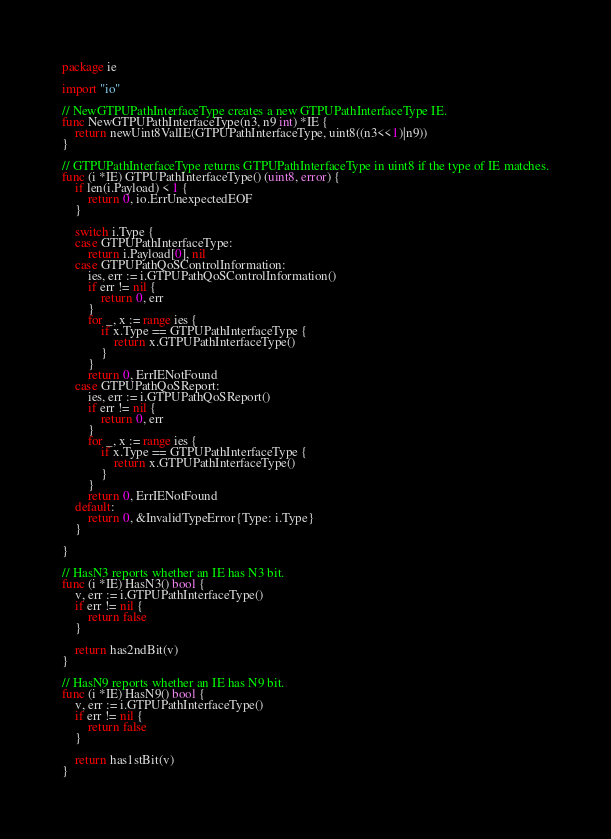<code> <loc_0><loc_0><loc_500><loc_500><_Go_>
package ie

import "io"

// NewGTPUPathInterfaceType creates a new GTPUPathInterfaceType IE.
func NewGTPUPathInterfaceType(n3, n9 int) *IE {
	return newUint8ValIE(GTPUPathInterfaceType, uint8((n3<<1)|n9))
}

// GTPUPathInterfaceType returns GTPUPathInterfaceType in uint8 if the type of IE matches.
func (i *IE) GTPUPathInterfaceType() (uint8, error) {
	if len(i.Payload) < 1 {
		return 0, io.ErrUnexpectedEOF
	}

	switch i.Type {
	case GTPUPathInterfaceType:
		return i.Payload[0], nil
	case GTPUPathQoSControlInformation:
		ies, err := i.GTPUPathQoSControlInformation()
		if err != nil {
			return 0, err
		}
		for _, x := range ies {
			if x.Type == GTPUPathInterfaceType {
				return x.GTPUPathInterfaceType()
			}
		}
		return 0, ErrIENotFound
	case GTPUPathQoSReport:
		ies, err := i.GTPUPathQoSReport()
		if err != nil {
			return 0, err
		}
		for _, x := range ies {
			if x.Type == GTPUPathInterfaceType {
				return x.GTPUPathInterfaceType()
			}
		}
		return 0, ErrIENotFound
	default:
		return 0, &InvalidTypeError{Type: i.Type}
	}

}

// HasN3 reports whether an IE has N3 bit.
func (i *IE) HasN3() bool {
	v, err := i.GTPUPathInterfaceType()
	if err != nil {
		return false
	}

	return has2ndBit(v)
}

// HasN9 reports whether an IE has N9 bit.
func (i *IE) HasN9() bool {
	v, err := i.GTPUPathInterfaceType()
	if err != nil {
		return false
	}

	return has1stBit(v)
}
</code> 